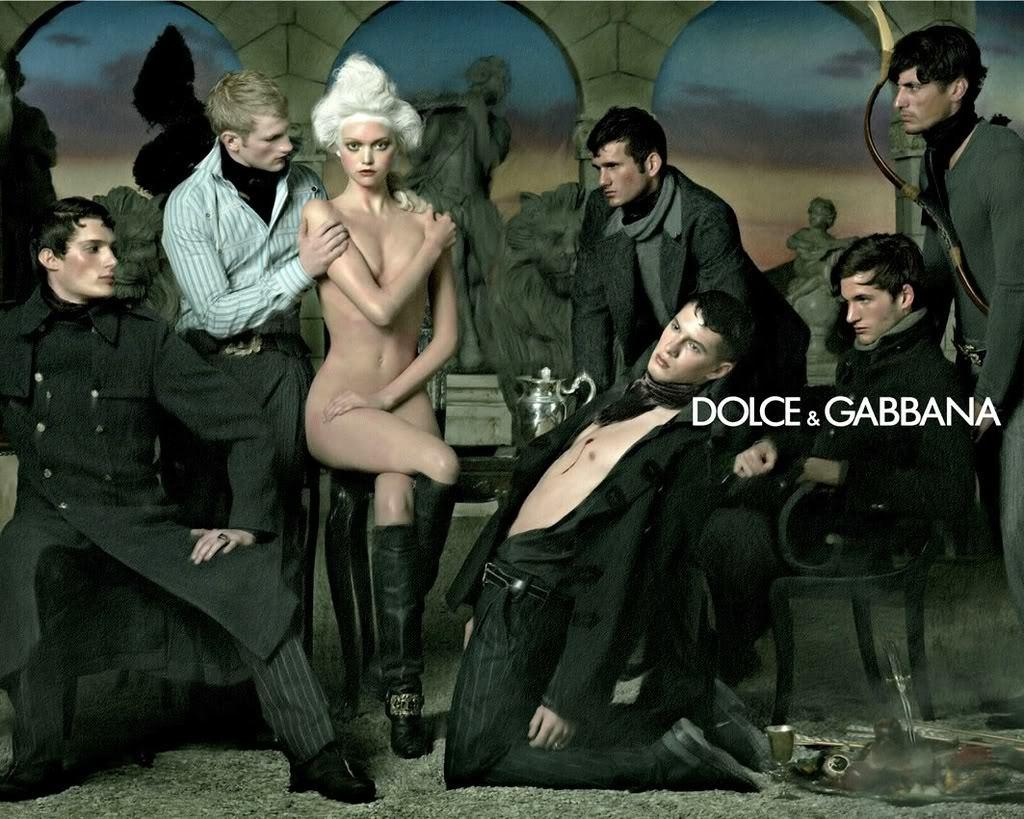What type of artwork is depicted in the image? The image is a painting. Who can be seen in the painting? There are women and men in the painting. What type of furniture is present in the painting? There are chairs in the painting. What architectural elements can be seen in the painting? There are statues and pillars in the painting. What is visible in the background of the painting? The sky is visible in the painting, and there are clouds present. How many friends are sitting in the box in the painting? There is no box present in the painting, and therefore no friends can be found sitting in it. 